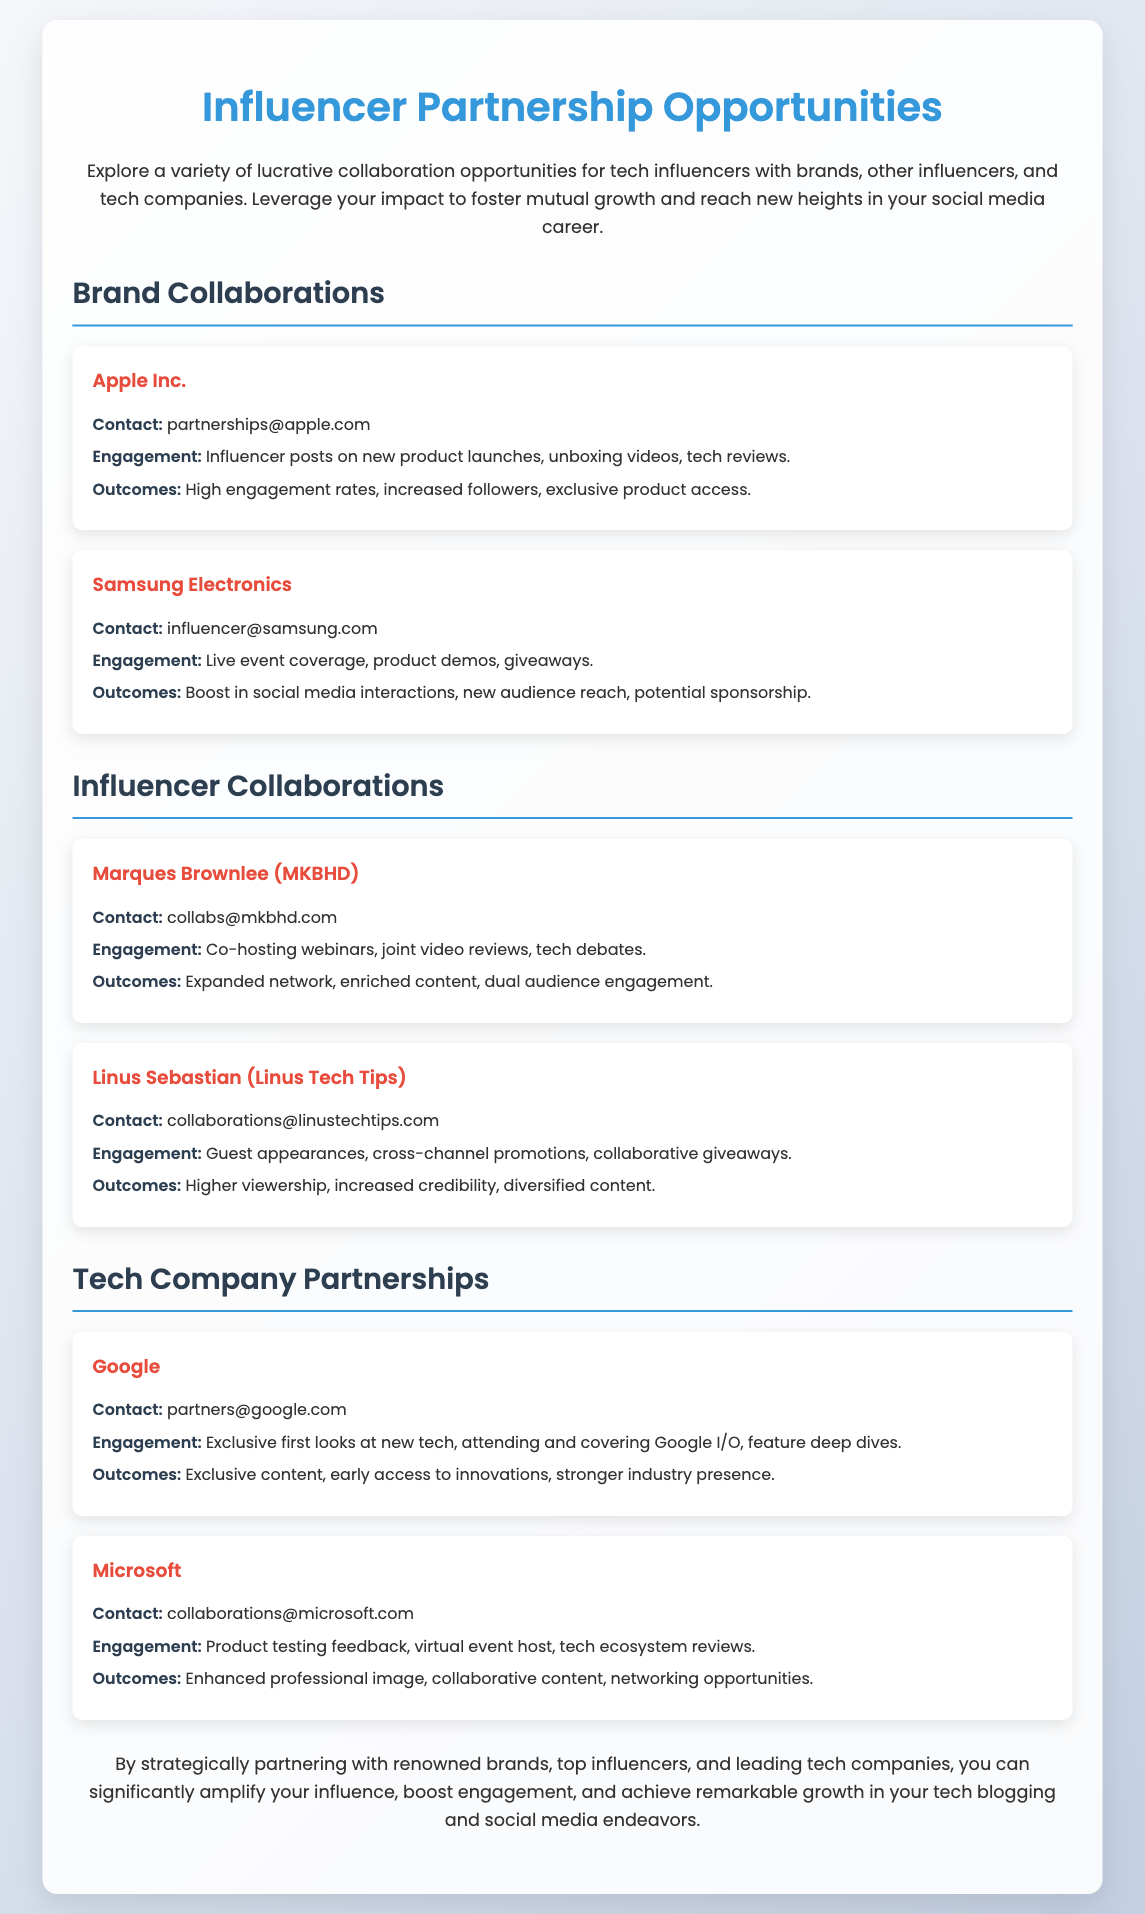what are the contact details for Apple? The document provides a contact email for Apple, which is partnerships@apple.com.
Answer: partnerships@apple.com who is mentioned as a potential collaborator from Linus Tech Tips? Linus Sebastian is mentioned in the document as a potential collaborator.
Answer: Linus Sebastian what type of engagement is proposed with Samsung Electronics? The document states that engagement with Samsung Electronics includes live event coverage, product demos, and giveaways.
Answer: Live event coverage, product demos, giveaways what are the projected outcomes of collaborating with Google? The document lists exclusive content, early access to innovations, and stronger industry presence as projected outcomes of collaborating with Google.
Answer: Exclusive content, early access to innovations, stronger industry presence which company's contact email is collaborations@microsoft.com? The email collaborations@microsoft.com belongs to Microsoft, as indicated in the document.
Answer: Microsoft how many influencer collaboration opportunities are mentioned? The document lists two influencer collaborations: Marques Brownlee and Linus Sebastian, totaling two opportunities.
Answer: 2 what is the main benefit of collaborating with brands according to the document? The document suggests that collaborating with brands can significantly amplify your influence.
Answer: Amplify your influence what type of collaborations does the document highlight? The document highlights brand collaborations, influencer collaborations, and tech company partnerships.
Answer: Brand collaborations, influencer collaborations, tech company partnerships 